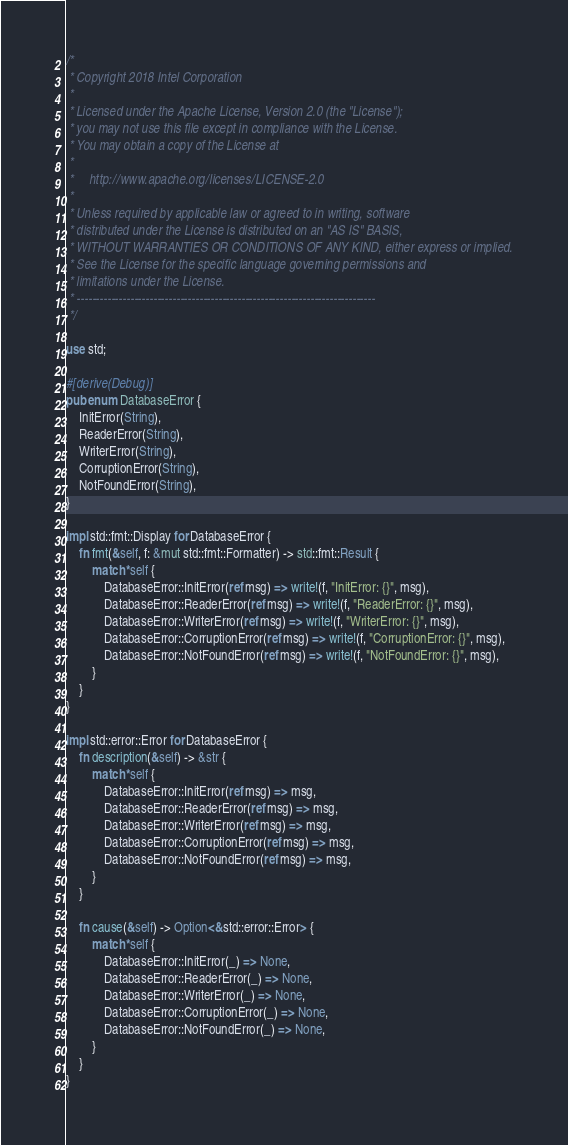Convert code to text. <code><loc_0><loc_0><loc_500><loc_500><_Rust_>/*
 * Copyright 2018 Intel Corporation
 *
 * Licensed under the Apache License, Version 2.0 (the "License");
 * you may not use this file except in compliance with the License.
 * You may obtain a copy of the License at
 *
 *     http://www.apache.org/licenses/LICENSE-2.0
 *
 * Unless required by applicable law or agreed to in writing, software
 * distributed under the License is distributed on an "AS IS" BASIS,
 * WITHOUT WARRANTIES OR CONDITIONS OF ANY KIND, either express or implied.
 * See the License for the specific language governing permissions and
 * limitations under the License.
 * ------------------------------------------------------------------------------
 */

use std;

#[derive(Debug)]
pub enum DatabaseError {
    InitError(String),
    ReaderError(String),
    WriterError(String),
    CorruptionError(String),
    NotFoundError(String),
}

impl std::fmt::Display for DatabaseError {
    fn fmt(&self, f: &mut std::fmt::Formatter) -> std::fmt::Result {
        match *self {
            DatabaseError::InitError(ref msg) => write!(f, "InitError: {}", msg),
            DatabaseError::ReaderError(ref msg) => write!(f, "ReaderError: {}", msg),
            DatabaseError::WriterError(ref msg) => write!(f, "WriterError: {}", msg),
            DatabaseError::CorruptionError(ref msg) => write!(f, "CorruptionError: {}", msg),
            DatabaseError::NotFoundError(ref msg) => write!(f, "NotFoundError: {}", msg),
        }
    }
}

impl std::error::Error for DatabaseError {
    fn description(&self) -> &str {
        match *self {
            DatabaseError::InitError(ref msg) => msg,
            DatabaseError::ReaderError(ref msg) => msg,
            DatabaseError::WriterError(ref msg) => msg,
            DatabaseError::CorruptionError(ref msg) => msg,
            DatabaseError::NotFoundError(ref msg) => msg,
        }
    }

    fn cause(&self) -> Option<&std::error::Error> {
        match *self {
            DatabaseError::InitError(_) => None,
            DatabaseError::ReaderError(_) => None,
            DatabaseError::WriterError(_) => None,
            DatabaseError::CorruptionError(_) => None,
            DatabaseError::NotFoundError(_) => None,
        }
    }
}
</code> 